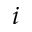Convert formula to latex. <formula><loc_0><loc_0><loc_500><loc_500>i</formula> 